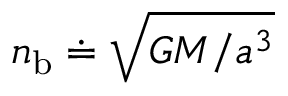<formula> <loc_0><loc_0><loc_500><loc_500>n _ { b } \doteq \sqrt { G M / a ^ { 3 } }</formula> 